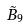<formula> <loc_0><loc_0><loc_500><loc_500>\tilde { B } _ { 9 }</formula> 